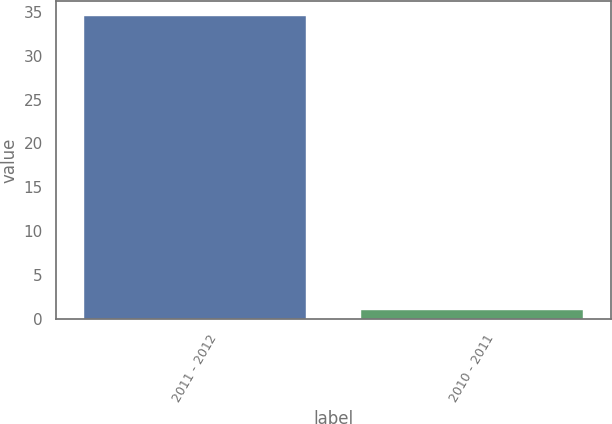Convert chart. <chart><loc_0><loc_0><loc_500><loc_500><bar_chart><fcel>2011 - 2012<fcel>2010 - 2011<nl><fcel>34.5<fcel>1.1<nl></chart> 